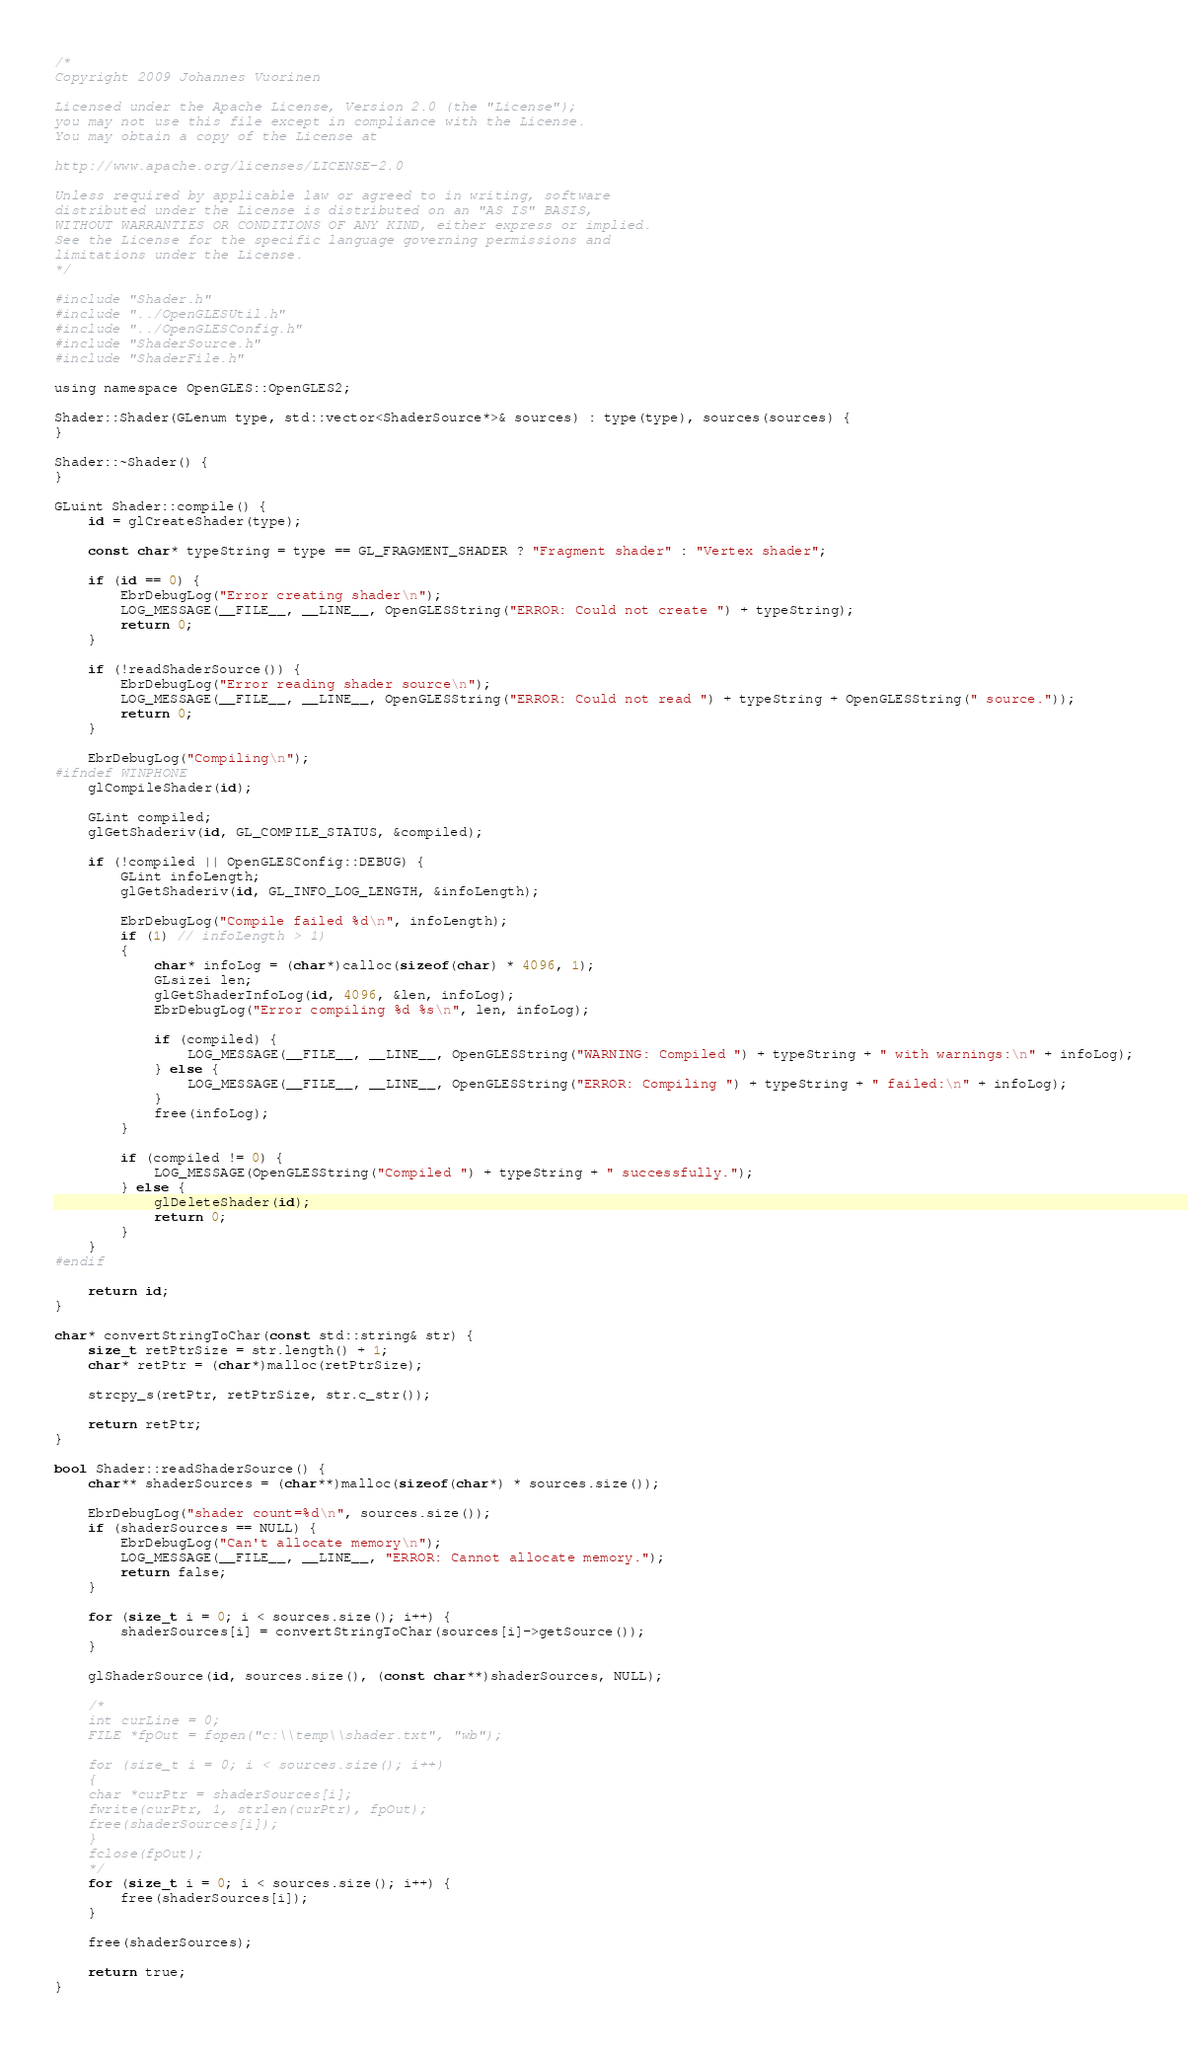Convert code to text. <code><loc_0><loc_0><loc_500><loc_500><_ObjectiveC_>/*
Copyright 2009 Johannes Vuorinen

Licensed under the Apache License, Version 2.0 (the "License");
you may not use this file except in compliance with the License.
You may obtain a copy of the License at

http://www.apache.org/licenses/LICENSE-2.0

Unless required by applicable law or agreed to in writing, software
distributed under the License is distributed on an "AS IS" BASIS,
WITHOUT WARRANTIES OR CONDITIONS OF ANY KIND, either express or implied.
See the License for the specific language governing permissions and
limitations under the License.
*/

#include "Shader.h"
#include "../OpenGLESUtil.h"
#include "../OpenGLESConfig.h"
#include "ShaderSource.h"
#include "ShaderFile.h"

using namespace OpenGLES::OpenGLES2;

Shader::Shader(GLenum type, std::vector<ShaderSource*>& sources) : type(type), sources(sources) {
}

Shader::~Shader() {
}

GLuint Shader::compile() {
    id = glCreateShader(type);

    const char* typeString = type == GL_FRAGMENT_SHADER ? "Fragment shader" : "Vertex shader";

    if (id == 0) {
        EbrDebugLog("Error creating shader\n");
        LOG_MESSAGE(__FILE__, __LINE__, OpenGLESString("ERROR: Could not create ") + typeString);
        return 0;
    }

    if (!readShaderSource()) {
        EbrDebugLog("Error reading shader source\n");
        LOG_MESSAGE(__FILE__, __LINE__, OpenGLESString("ERROR: Could not read ") + typeString + OpenGLESString(" source."));
        return 0;
    }

    EbrDebugLog("Compiling\n");
#ifndef WINPHONE
    glCompileShader(id);

    GLint compiled;
    glGetShaderiv(id, GL_COMPILE_STATUS, &compiled);

    if (!compiled || OpenGLESConfig::DEBUG) {
        GLint infoLength;
        glGetShaderiv(id, GL_INFO_LOG_LENGTH, &infoLength);

        EbrDebugLog("Compile failed %d\n", infoLength);
        if (1) // infoLength > 1)
        {
            char* infoLog = (char*)calloc(sizeof(char) * 4096, 1);
            GLsizei len;
            glGetShaderInfoLog(id, 4096, &len, infoLog);
            EbrDebugLog("Error compiling %d %s\n", len, infoLog);

            if (compiled) {
                LOG_MESSAGE(__FILE__, __LINE__, OpenGLESString("WARNING: Compiled ") + typeString + " with warnings:\n" + infoLog);
            } else {
                LOG_MESSAGE(__FILE__, __LINE__, OpenGLESString("ERROR: Compiling ") + typeString + " failed:\n" + infoLog);
            }
            free(infoLog);
        }

        if (compiled != 0) {
            LOG_MESSAGE(OpenGLESString("Compiled ") + typeString + " successfully.");
        } else {
            glDeleteShader(id);
            return 0;
        }
    }
#endif

    return id;
}

char* convertStringToChar(const std::string& str) {
    size_t retPtrSize = str.length() + 1;
    char* retPtr = (char*)malloc(retPtrSize);

    strcpy_s(retPtr, retPtrSize, str.c_str());

    return retPtr;
}

bool Shader::readShaderSource() {
    char** shaderSources = (char**)malloc(sizeof(char*) * sources.size());

    EbrDebugLog("shader count=%d\n", sources.size());
    if (shaderSources == NULL) {
        EbrDebugLog("Can't allocate memory\n");
        LOG_MESSAGE(__FILE__, __LINE__, "ERROR: Cannot allocate memory.");
        return false;
    }

    for (size_t i = 0; i < sources.size(); i++) {
        shaderSources[i] = convertStringToChar(sources[i]->getSource());
    }

    glShaderSource(id, sources.size(), (const char**)shaderSources, NULL);

    /*
    int curLine = 0;
    FILE *fpOut = fopen("c:\\temp\\shader.txt", "wb");

    for (size_t i = 0; i < sources.size(); i++)
    {
    char *curPtr = shaderSources[i];
    fwrite(curPtr, 1, strlen(curPtr), fpOut);
    free(shaderSources[i]);
    }
    fclose(fpOut);
    */
    for (size_t i = 0; i < sources.size(); i++) {
        free(shaderSources[i]);
    }

    free(shaderSources);

    return true;
}
</code> 